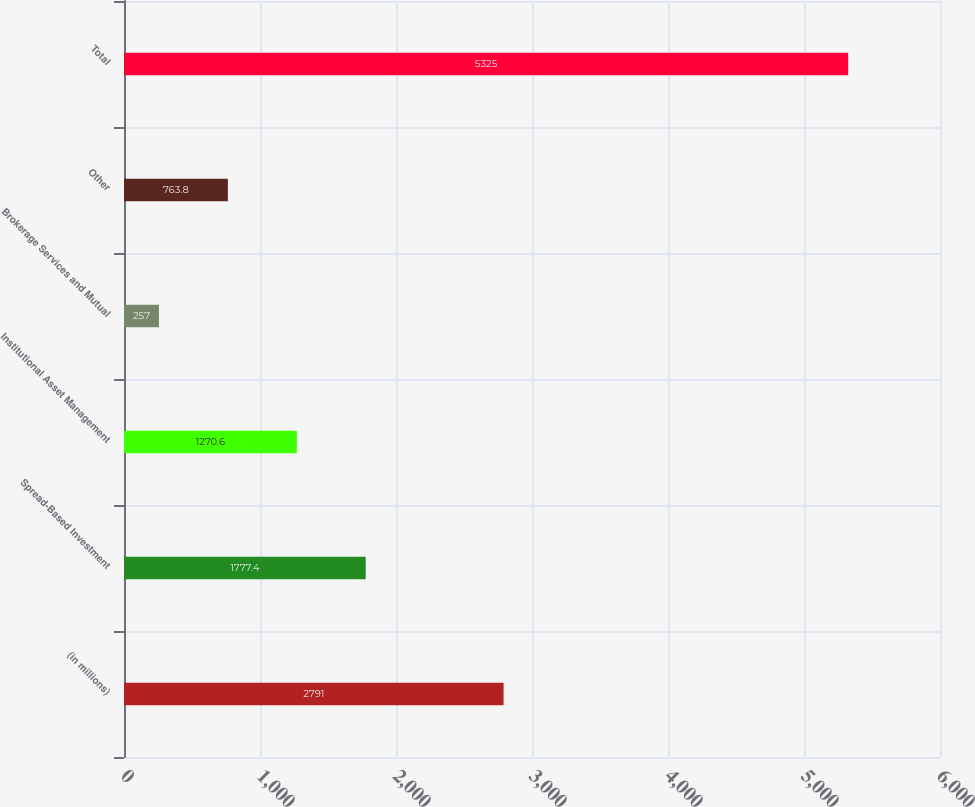Convert chart. <chart><loc_0><loc_0><loc_500><loc_500><bar_chart><fcel>(in millions)<fcel>Spread-Based Investment<fcel>Institutional Asset Management<fcel>Brokerage Services and Mutual<fcel>Other<fcel>Total<nl><fcel>2791<fcel>1777.4<fcel>1270.6<fcel>257<fcel>763.8<fcel>5325<nl></chart> 